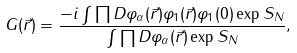<formula> <loc_0><loc_0><loc_500><loc_500>G ( \vec { r } ) = \frac { - i \int \prod D \varphi _ { \alpha } ( \vec { r } ) \varphi _ { 1 } ( \vec { r } ) \varphi _ { 1 } ( 0 ) \exp S _ { N } } { \int \prod D \varphi _ { \alpha } ( \vec { r } ) \exp S _ { N } } ,</formula> 